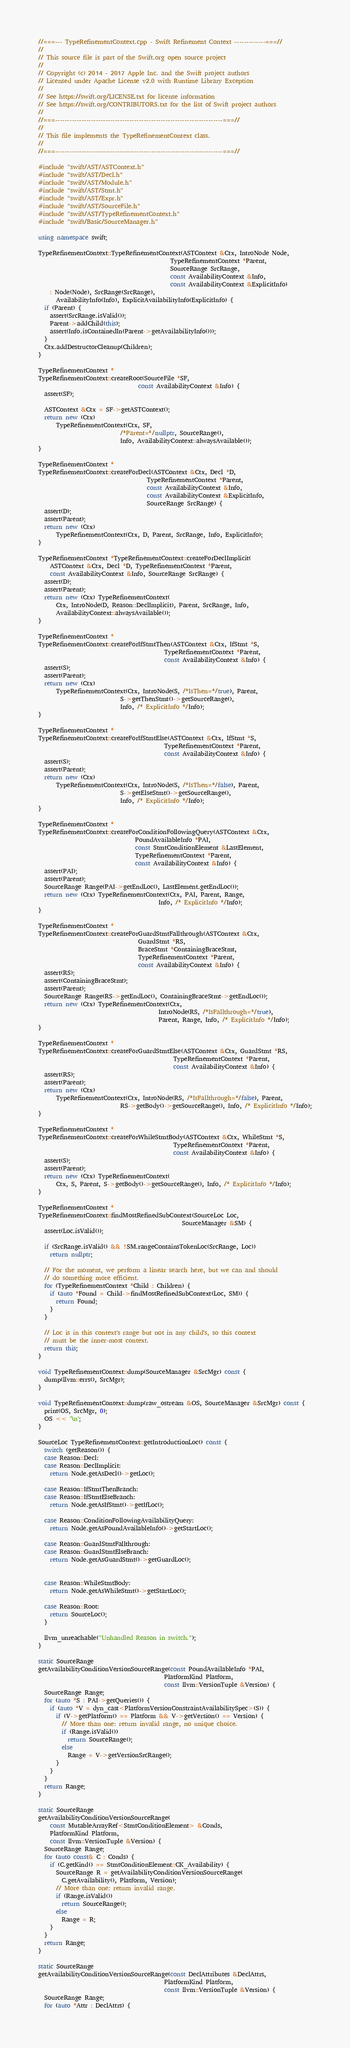Convert code to text. <code><loc_0><loc_0><loc_500><loc_500><_C++_>//===--- TypeRefinementContext.cpp - Swift Refinement Context -------------===//
//
// This source file is part of the Swift.org open source project
//
// Copyright (c) 2014 - 2017 Apple Inc. and the Swift project authors
// Licensed under Apache License v2.0 with Runtime Library Exception
//
// See https://swift.org/LICENSE.txt for license information
// See https://swift.org/CONTRIBUTORS.txt for the list of Swift project authors
//
//===----------------------------------------------------------------------===//
//
// This file implements the TypeRefinementContext class.
//
//===----------------------------------------------------------------------===//

#include "swift/AST/ASTContext.h"
#include "swift/AST/Decl.h"
#include "swift/AST/Module.h"
#include "swift/AST/Stmt.h"
#include "swift/AST/Expr.h"
#include "swift/AST/SourceFile.h"
#include "swift/AST/TypeRefinementContext.h"
#include "swift/Basic/SourceManager.h"

using namespace swift;

TypeRefinementContext::TypeRefinementContext(ASTContext &Ctx, IntroNode Node,
                                             TypeRefinementContext *Parent,
                                             SourceRange SrcRange,
                                             const AvailabilityContext &Info,
                                             const AvailabilityContext &ExplicitInfo)
    : Node(Node), SrcRange(SrcRange),
      AvailabilityInfo(Info), ExplicitAvailabilityInfo(ExplicitInfo) {
  if (Parent) {
    assert(SrcRange.isValid());
    Parent->addChild(this);
    assert(Info.isContainedIn(Parent->getAvailabilityInfo()));
  }
  Ctx.addDestructorCleanup(Children);
}

TypeRefinementContext *
TypeRefinementContext::createRoot(SourceFile *SF,
                                  const AvailabilityContext &Info) {
  assert(SF);

  ASTContext &Ctx = SF->getASTContext();
  return new (Ctx)
      TypeRefinementContext(Ctx, SF,
                            /*Parent=*/nullptr, SourceRange(),
                            Info, AvailabilityContext::alwaysAvailable());
}

TypeRefinementContext *
TypeRefinementContext::createForDecl(ASTContext &Ctx, Decl *D,
                                     TypeRefinementContext *Parent,
                                     const AvailabilityContext &Info,
                                     const AvailabilityContext &ExplicitInfo,
                                     SourceRange SrcRange) {
  assert(D);
  assert(Parent);
  return new (Ctx)
      TypeRefinementContext(Ctx, D, Parent, SrcRange, Info, ExplicitInfo);
}

TypeRefinementContext *TypeRefinementContext::createForDeclImplicit(
    ASTContext &Ctx, Decl *D, TypeRefinementContext *Parent,
    const AvailabilityContext &Info, SourceRange SrcRange) {
  assert(D);
  assert(Parent);
  return new (Ctx) TypeRefinementContext(
      Ctx, IntroNode(D, Reason::DeclImplicit), Parent, SrcRange, Info,
      AvailabilityContext::alwaysAvailable());
}

TypeRefinementContext *
TypeRefinementContext::createForIfStmtThen(ASTContext &Ctx, IfStmt *S,
                                           TypeRefinementContext *Parent,
                                           const AvailabilityContext &Info) {
  assert(S);
  assert(Parent);
  return new (Ctx)
      TypeRefinementContext(Ctx, IntroNode(S, /*IsThen=*/true), Parent,
                            S->getThenStmt()->getSourceRange(),
                            Info, /* ExplicitInfo */Info);
}

TypeRefinementContext *
TypeRefinementContext::createForIfStmtElse(ASTContext &Ctx, IfStmt *S,
                                           TypeRefinementContext *Parent,
                                           const AvailabilityContext &Info) {
  assert(S);
  assert(Parent);
  return new (Ctx)
      TypeRefinementContext(Ctx, IntroNode(S, /*IsThen=*/false), Parent,
                            S->getElseStmt()->getSourceRange(),
                            Info, /* ExplicitInfo */Info);
}

TypeRefinementContext *
TypeRefinementContext::createForConditionFollowingQuery(ASTContext &Ctx,
                                 PoundAvailableInfo *PAI,
                                 const StmtConditionElement &LastElement,
                                 TypeRefinementContext *Parent,
                                 const AvailabilityContext &Info) {
  assert(PAI);
  assert(Parent);
  SourceRange Range(PAI->getEndLoc(), LastElement.getEndLoc());
  return new (Ctx) TypeRefinementContext(Ctx, PAI, Parent, Range,
                                         Info, /* ExplicitInfo */Info);
}

TypeRefinementContext *
TypeRefinementContext::createForGuardStmtFallthrough(ASTContext &Ctx,
                                  GuardStmt *RS,
                                  BraceStmt *ContainingBraceStmt,
                                  TypeRefinementContext *Parent,
                                  const AvailabilityContext &Info) {
  assert(RS);
  assert(ContainingBraceStmt);
  assert(Parent);
  SourceRange Range(RS->getEndLoc(), ContainingBraceStmt->getEndLoc());
  return new (Ctx) TypeRefinementContext(Ctx,
                                         IntroNode(RS, /*IsFallthrough=*/true),
                                         Parent, Range, Info, /* ExplicitInfo */Info);
}

TypeRefinementContext *
TypeRefinementContext::createForGuardStmtElse(ASTContext &Ctx, GuardStmt *RS,
                                              TypeRefinementContext *Parent,
                                              const AvailabilityContext &Info) {
  assert(RS);
  assert(Parent);
  return new (Ctx)
      TypeRefinementContext(Ctx, IntroNode(RS, /*IsFallthrough=*/false), Parent,
                            RS->getBody()->getSourceRange(), Info, /* ExplicitInfo */Info);
}

TypeRefinementContext *
TypeRefinementContext::createForWhileStmtBody(ASTContext &Ctx, WhileStmt *S,
                                              TypeRefinementContext *Parent,
                                              const AvailabilityContext &Info) {
  assert(S);
  assert(Parent);
  return new (Ctx) TypeRefinementContext(
      Ctx, S, Parent, S->getBody()->getSourceRange(), Info, /* ExplicitInfo */Info);
}

TypeRefinementContext *
TypeRefinementContext::findMostRefinedSubContext(SourceLoc Loc,
                                                 SourceManager &SM) {
  assert(Loc.isValid());
  
  if (SrcRange.isValid() && !SM.rangeContainsTokenLoc(SrcRange, Loc))
    return nullptr;

  // For the moment, we perform a linear search here, but we can and should
  // do something more efficient.
  for (TypeRefinementContext *Child : Children) {
    if (auto *Found = Child->findMostRefinedSubContext(Loc, SM)) {
      return Found;
    }
  }

  // Loc is in this context's range but not in any child's, so this context
  // must be the inner-most context.
  return this;
}

void TypeRefinementContext::dump(SourceManager &SrcMgr) const {
  dump(llvm::errs(), SrcMgr);
}

void TypeRefinementContext::dump(raw_ostream &OS, SourceManager &SrcMgr) const {
  print(OS, SrcMgr, 0);
  OS << '\n';
}

SourceLoc TypeRefinementContext::getIntroductionLoc() const {
  switch (getReason()) {
  case Reason::Decl:
  case Reason::DeclImplicit:
    return Node.getAsDecl()->getLoc();

  case Reason::IfStmtThenBranch:
  case Reason::IfStmtElseBranch:
    return Node.getAsIfStmt()->getIfLoc();

  case Reason::ConditionFollowingAvailabilityQuery:
    return Node.getAsPoundAvailableInfo()->getStartLoc();

  case Reason::GuardStmtFallthrough:
  case Reason::GuardStmtElseBranch:
    return Node.getAsGuardStmt()->getGuardLoc();


  case Reason::WhileStmtBody:
    return Node.getAsWhileStmt()->getStartLoc();

  case Reason::Root:
    return SourceLoc();
  }

  llvm_unreachable("Unhandled Reason in switch.");
}

static SourceRange
getAvailabilityConditionVersionSourceRange(const PoundAvailableInfo *PAI,
                                           PlatformKind Platform,
                                           const llvm::VersionTuple &Version) {
  SourceRange Range;
  for (auto *S : PAI->getQueries()) {
    if (auto *V = dyn_cast<PlatformVersionConstraintAvailabilitySpec>(S)) {
      if (V->getPlatform() == Platform && V->getVersion() == Version) {
        // More than one: return invalid range, no unique choice.
        if (Range.isValid())
          return SourceRange();
        else
          Range = V->getVersionSrcRange();
      }
    }
  }
  return Range;
}

static SourceRange
getAvailabilityConditionVersionSourceRange(
    const MutableArrayRef<StmtConditionElement> &Conds,
    PlatformKind Platform,
    const llvm::VersionTuple &Version) {
  SourceRange Range;
  for (auto const& C : Conds) {
    if (C.getKind() == StmtConditionElement::CK_Availability) {
      SourceRange R = getAvailabilityConditionVersionSourceRange(
        C.getAvailability(), Platform, Version);
      // More than one: return invalid range.
      if (Range.isValid())
        return SourceRange();
      else
        Range = R;
    }
  }
  return Range;
}

static SourceRange
getAvailabilityConditionVersionSourceRange(const DeclAttributes &DeclAttrs,
                                           PlatformKind Platform,
                                           const llvm::VersionTuple &Version) {
  SourceRange Range;
  for (auto *Attr : DeclAttrs) {</code> 